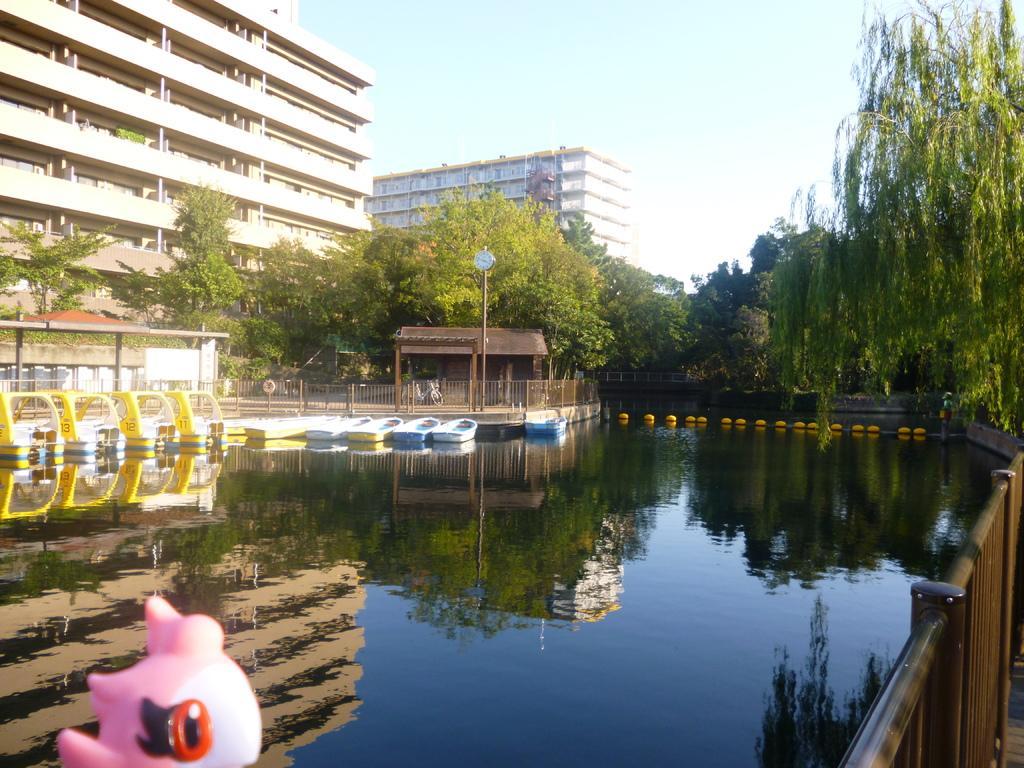Please provide a concise description of this image. In this picture we can see boats on water, here we can see a toy, fence, shelters, bicycle and a clock attached to the pole and some objects and in the background we can see buildings, trees, sky. 